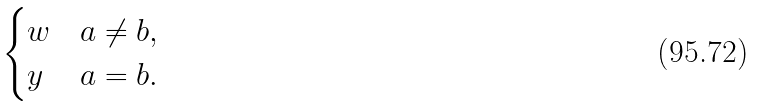Convert formula to latex. <formula><loc_0><loc_0><loc_500><loc_500>\begin{cases} w & a \neq b , \\ y & a = b . \end{cases}</formula> 